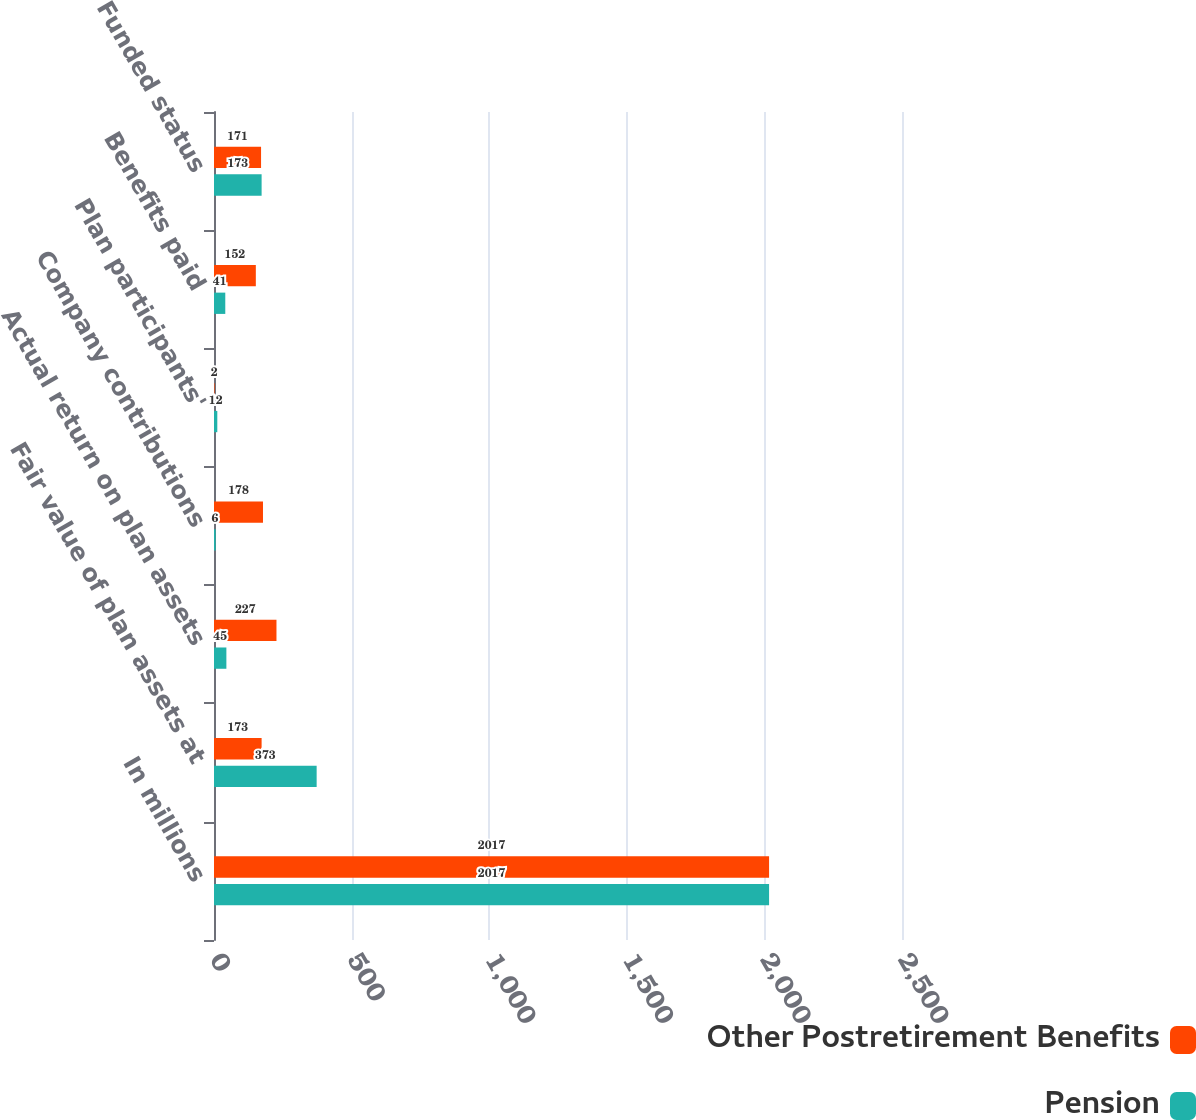<chart> <loc_0><loc_0><loc_500><loc_500><stacked_bar_chart><ecel><fcel>In millions<fcel>Fair value of plan assets at<fcel>Actual return on plan assets<fcel>Company contributions<fcel>Plan participants'<fcel>Benefits paid<fcel>Funded status<nl><fcel>Other Postretirement Benefits<fcel>2017<fcel>173<fcel>227<fcel>178<fcel>2<fcel>152<fcel>171<nl><fcel>Pension<fcel>2017<fcel>373<fcel>45<fcel>6<fcel>12<fcel>41<fcel>173<nl></chart> 